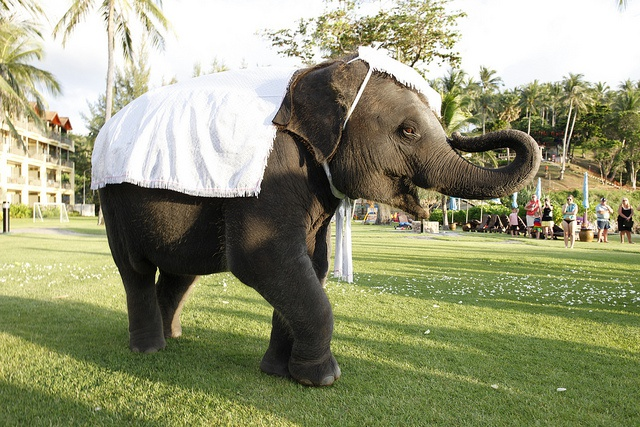Describe the objects in this image and their specific colors. I can see elephant in olive, black, white, and gray tones, people in olive, ivory, darkgray, tan, and gray tones, people in olive, black, gray, maroon, and tan tones, people in olive, ivory, tan, gray, and darkgray tones, and people in olive, darkgray, brown, white, and tan tones in this image. 